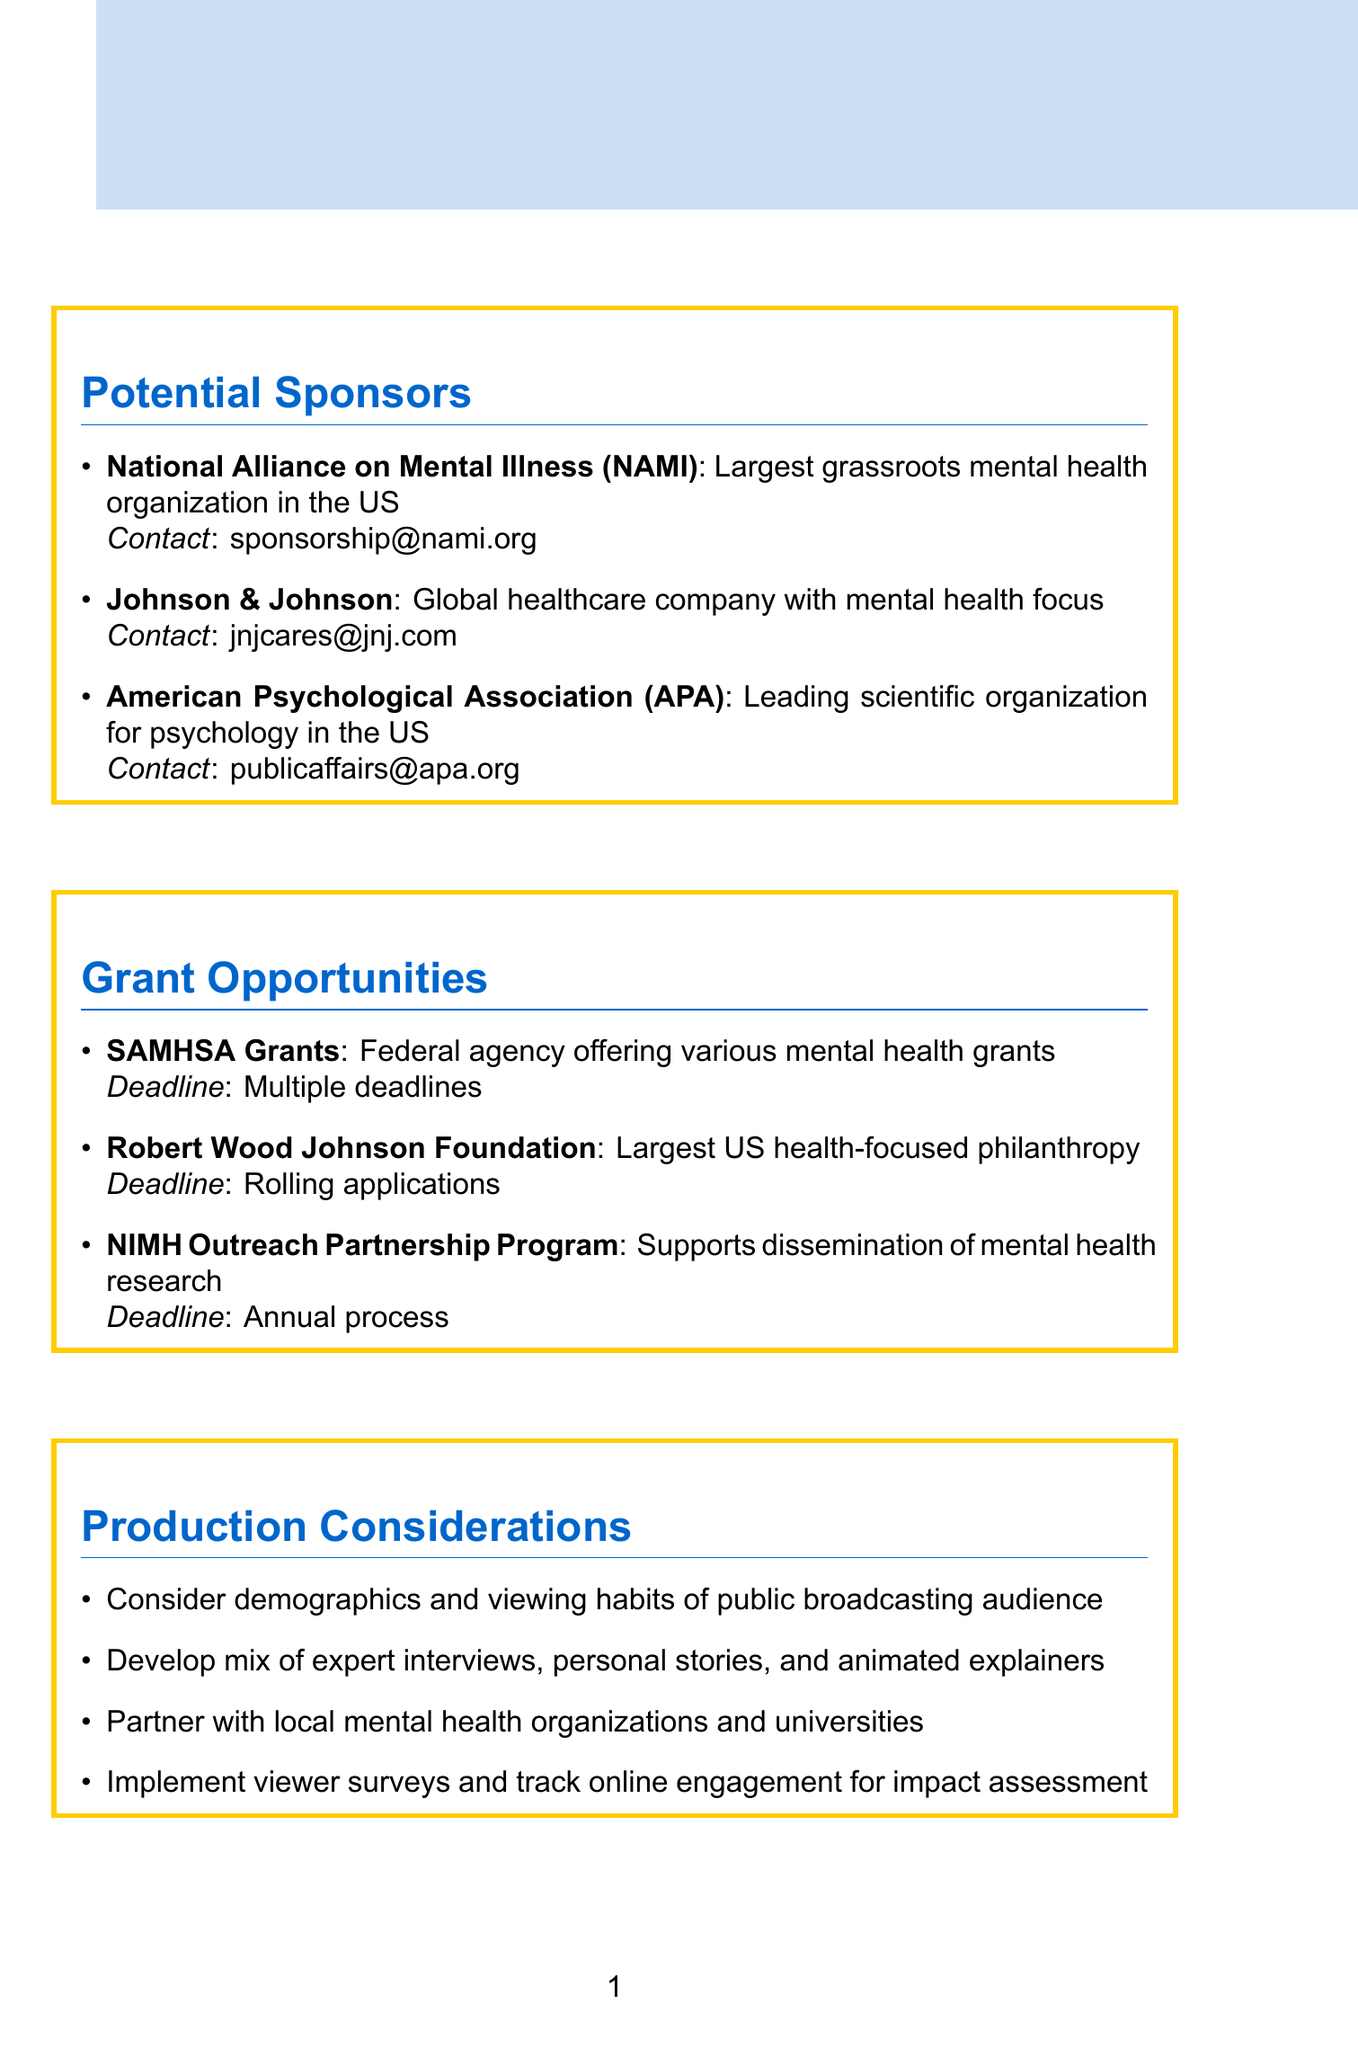What is the name of the largest grassroots mental health organization in the US? The document identifies the National Alliance on Mental Illness (NAMI) as the largest grassroots mental health organization in the US.
Answer: National Alliance on Mental Illness (NAMI) What type of sponsorship does Johnson & Johnson offer? The document states that Johnson & Johnson provides corporate sponsorship.
Answer: Corporate sponsorship How many expert advisors are listed in the memo? The document lists a total of three expert advisors.
Answer: Three What type of grants does the SAMHSA provide? The document indicates that SAMHSA Grants are for mental health awareness and treatment programs.
Answer: Mental health awareness and treatment programs What is the application deadline for the National Institute of Mental Health Outreach Partnership Program? According to the document, the National Institute of Mental Health (NIMH) has an annual application process for its Outreach Partnership Program.
Answer: Annual application process Which potential topic addresses the relationship between mental health and physical health? The document explicitly mentions "Intersection of mental health and physical health" as a potential topic.
Answer: Intersection of mental health and physical health What is one production consideration regarding audience demographics? The document highlights the importance of considering the demographics, viewing habits, and mental health literacy levels of public broadcasting viewers.
Answer: Demographics, viewing habits, mental health literacy levels Who is the director of Mental Health Policy at the University of California, Berkeley? The document lists Professor Sarah Thompson as the Director of Mental Health Policy at the University of California, Berkeley.
Answer: Professor Sarah Thompson 